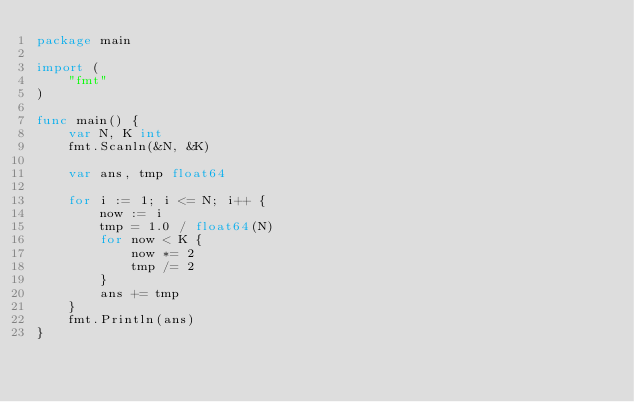<code> <loc_0><loc_0><loc_500><loc_500><_Go_>package main

import (
	"fmt"
)

func main() {
	var N, K int
	fmt.Scanln(&N, &K)

	var ans, tmp float64

	for i := 1; i <= N; i++ {
		now := i
		tmp = 1.0 / float64(N)
		for now < K {
			now *= 2
			tmp /= 2
		}
		ans += tmp
	}
	fmt.Println(ans)
}
</code> 